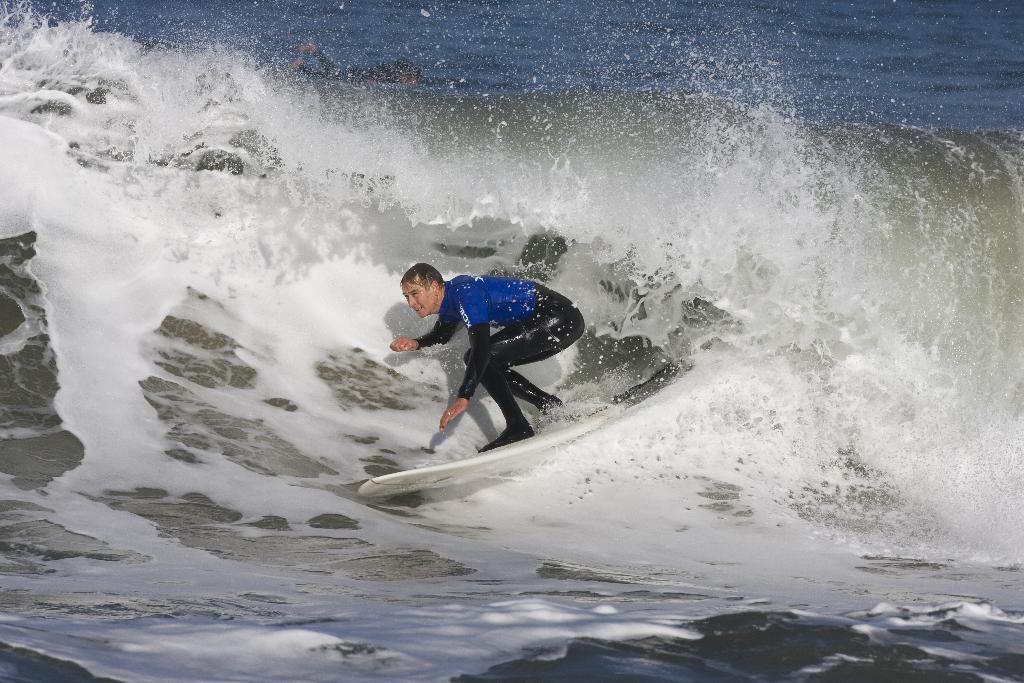What is the main subject of the image? There is a person in the image. What activity is the person engaged in? The person is surfing. Where is the surfing taking place? The surfing is taking place on the sea. What type of sign can be seen in the image? There is no sign present in the image. 